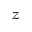<formula> <loc_0><loc_0><loc_500><loc_500>_ { z }</formula> 